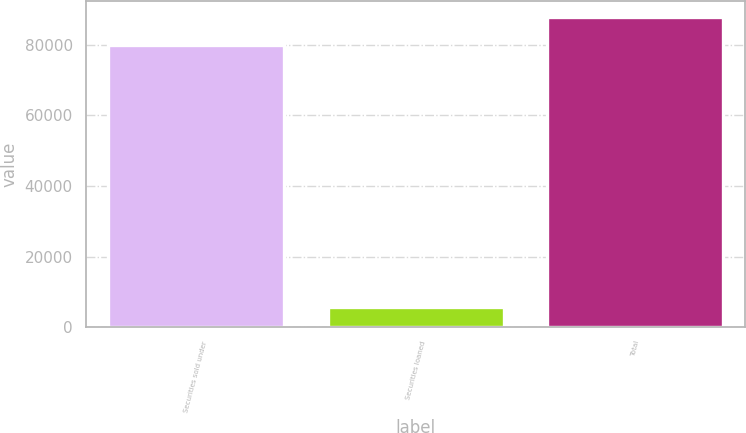Convert chart. <chart><loc_0><loc_0><loc_500><loc_500><bar_chart><fcel>Securities sold under<fcel>Securities loaned<fcel>Total<nl><fcel>79913<fcel>5658<fcel>87904.3<nl></chart> 